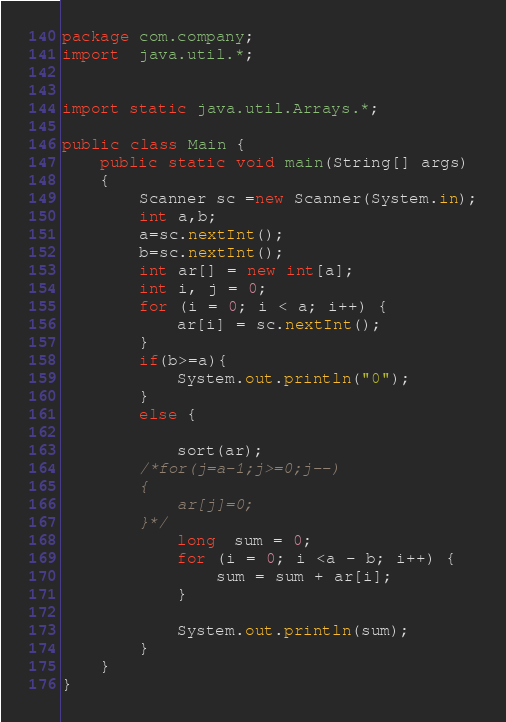Convert code to text. <code><loc_0><loc_0><loc_500><loc_500><_Java_>package com.company;
import  java.util.*;


import static java.util.Arrays.*;

public class Main {
    public static void main(String[] args)
    {
        Scanner sc =new Scanner(System.in);
        int a,b;
        a=sc.nextInt();
        b=sc.nextInt();
        int ar[] = new int[a];
        int i, j = 0;
        for (i = 0; i < a; i++) {
            ar[i] = sc.nextInt();
        }
        if(b>=a){
            System.out.println("0");
        }
        else {

            sort(ar);
        /*for(j=a-1;j>=0;j--)
        {
            ar[j]=0;
        }*/
            long  sum = 0;
            for (i = 0; i <a - b; i++) {
                sum = sum + ar[i];
            }

            System.out.println(sum);
        }
    }
}
</code> 